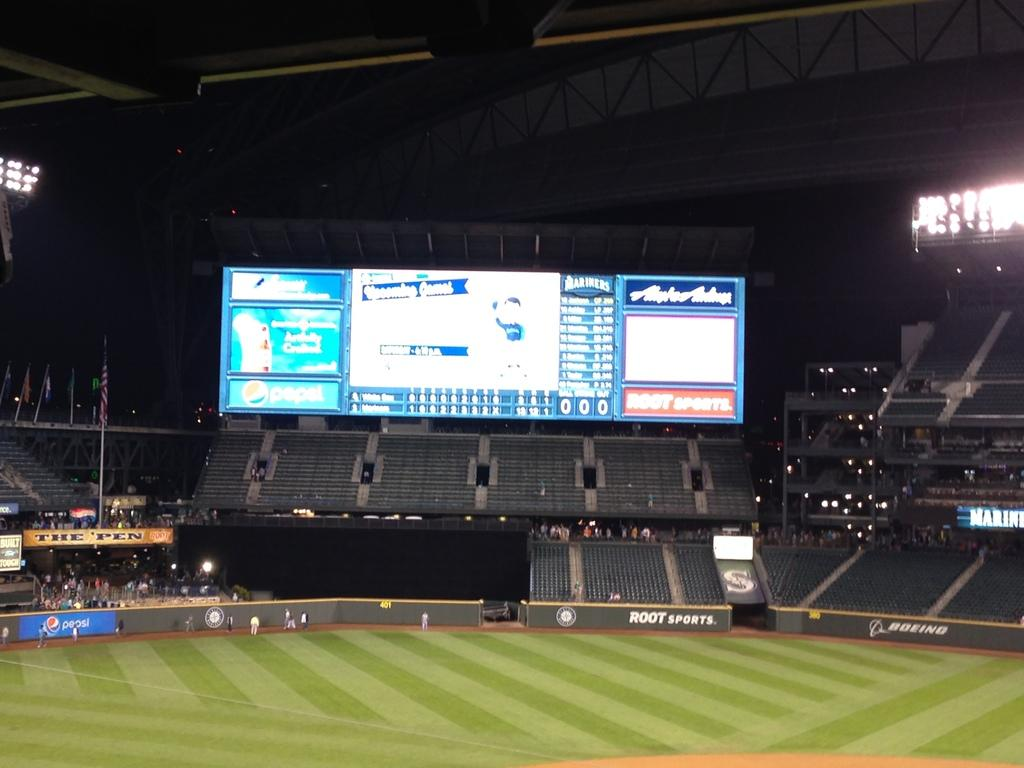<image>
Summarize the visual content of the image. Empty baseball field at night, with Root Sports emblem on the bleachers. 